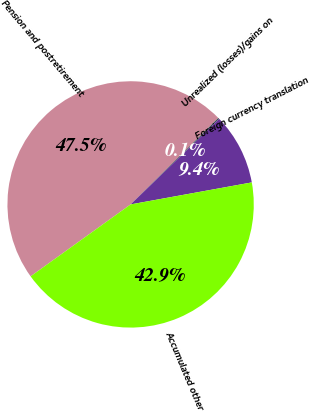Convert chart. <chart><loc_0><loc_0><loc_500><loc_500><pie_chart><fcel>Pension and postretirement<fcel>Unrealized (losses)/gains on<fcel>Foreign currency translation<fcel>Accumulated other<nl><fcel>47.55%<fcel>0.15%<fcel>9.37%<fcel>42.94%<nl></chart> 